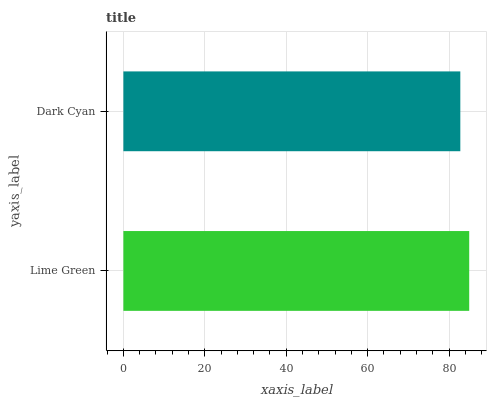Is Dark Cyan the minimum?
Answer yes or no. Yes. Is Lime Green the maximum?
Answer yes or no. Yes. Is Dark Cyan the maximum?
Answer yes or no. No. Is Lime Green greater than Dark Cyan?
Answer yes or no. Yes. Is Dark Cyan less than Lime Green?
Answer yes or no. Yes. Is Dark Cyan greater than Lime Green?
Answer yes or no. No. Is Lime Green less than Dark Cyan?
Answer yes or no. No. Is Lime Green the high median?
Answer yes or no. Yes. Is Dark Cyan the low median?
Answer yes or no. Yes. Is Dark Cyan the high median?
Answer yes or no. No. Is Lime Green the low median?
Answer yes or no. No. 